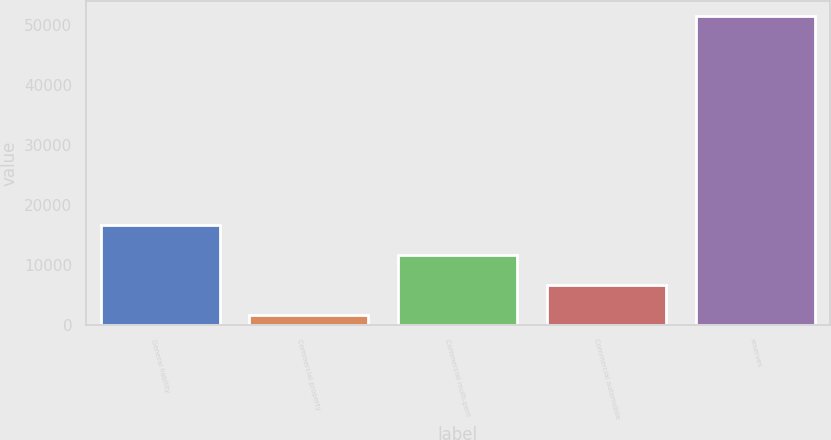Convert chart to OTSL. <chart><loc_0><loc_0><loc_500><loc_500><bar_chart><fcel>General liability<fcel>Commercial property<fcel>Commercial multi-peril<fcel>Commercial automobile<fcel>reserves<nl><fcel>16585.2<fcel>1668<fcel>11612.8<fcel>6640.4<fcel>51392<nl></chart> 